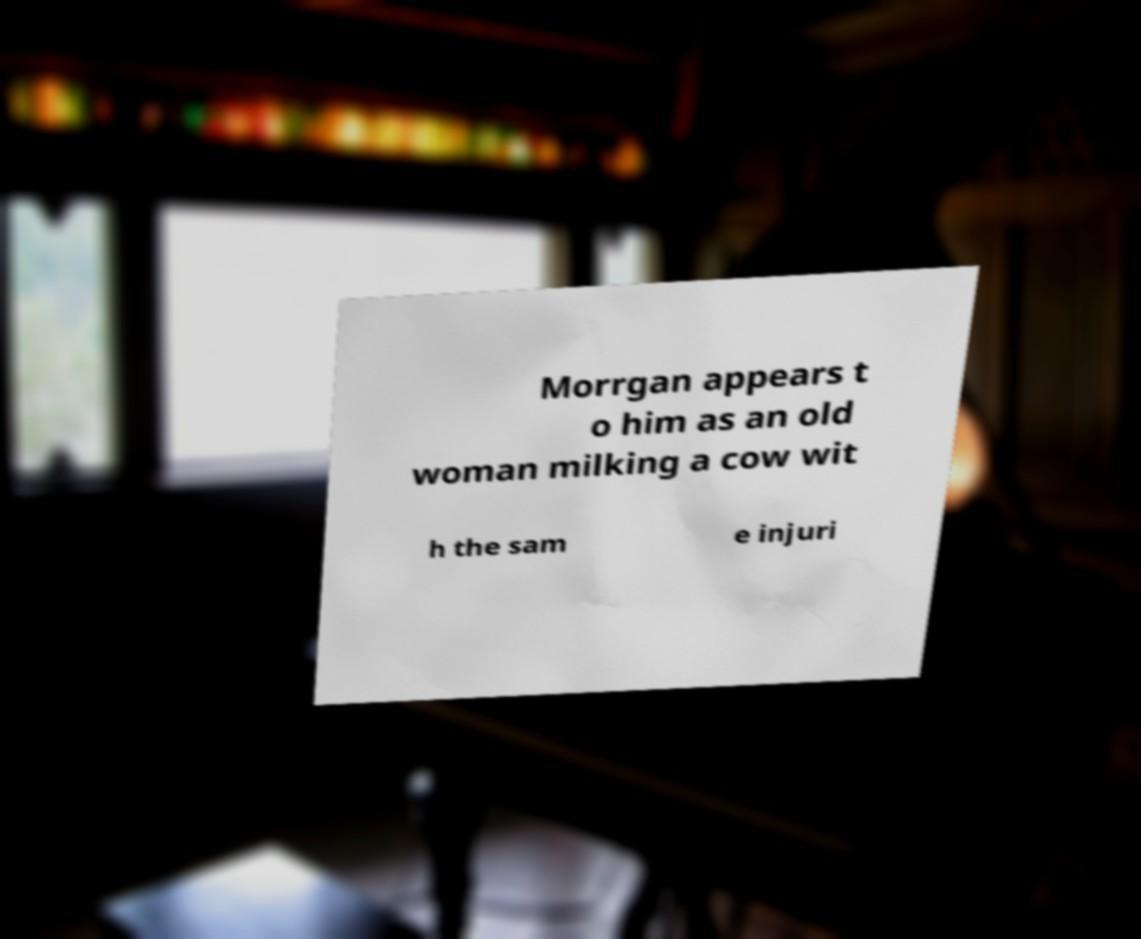What messages or text are displayed in this image? I need them in a readable, typed format. Morrgan appears t o him as an old woman milking a cow wit h the sam e injuri 